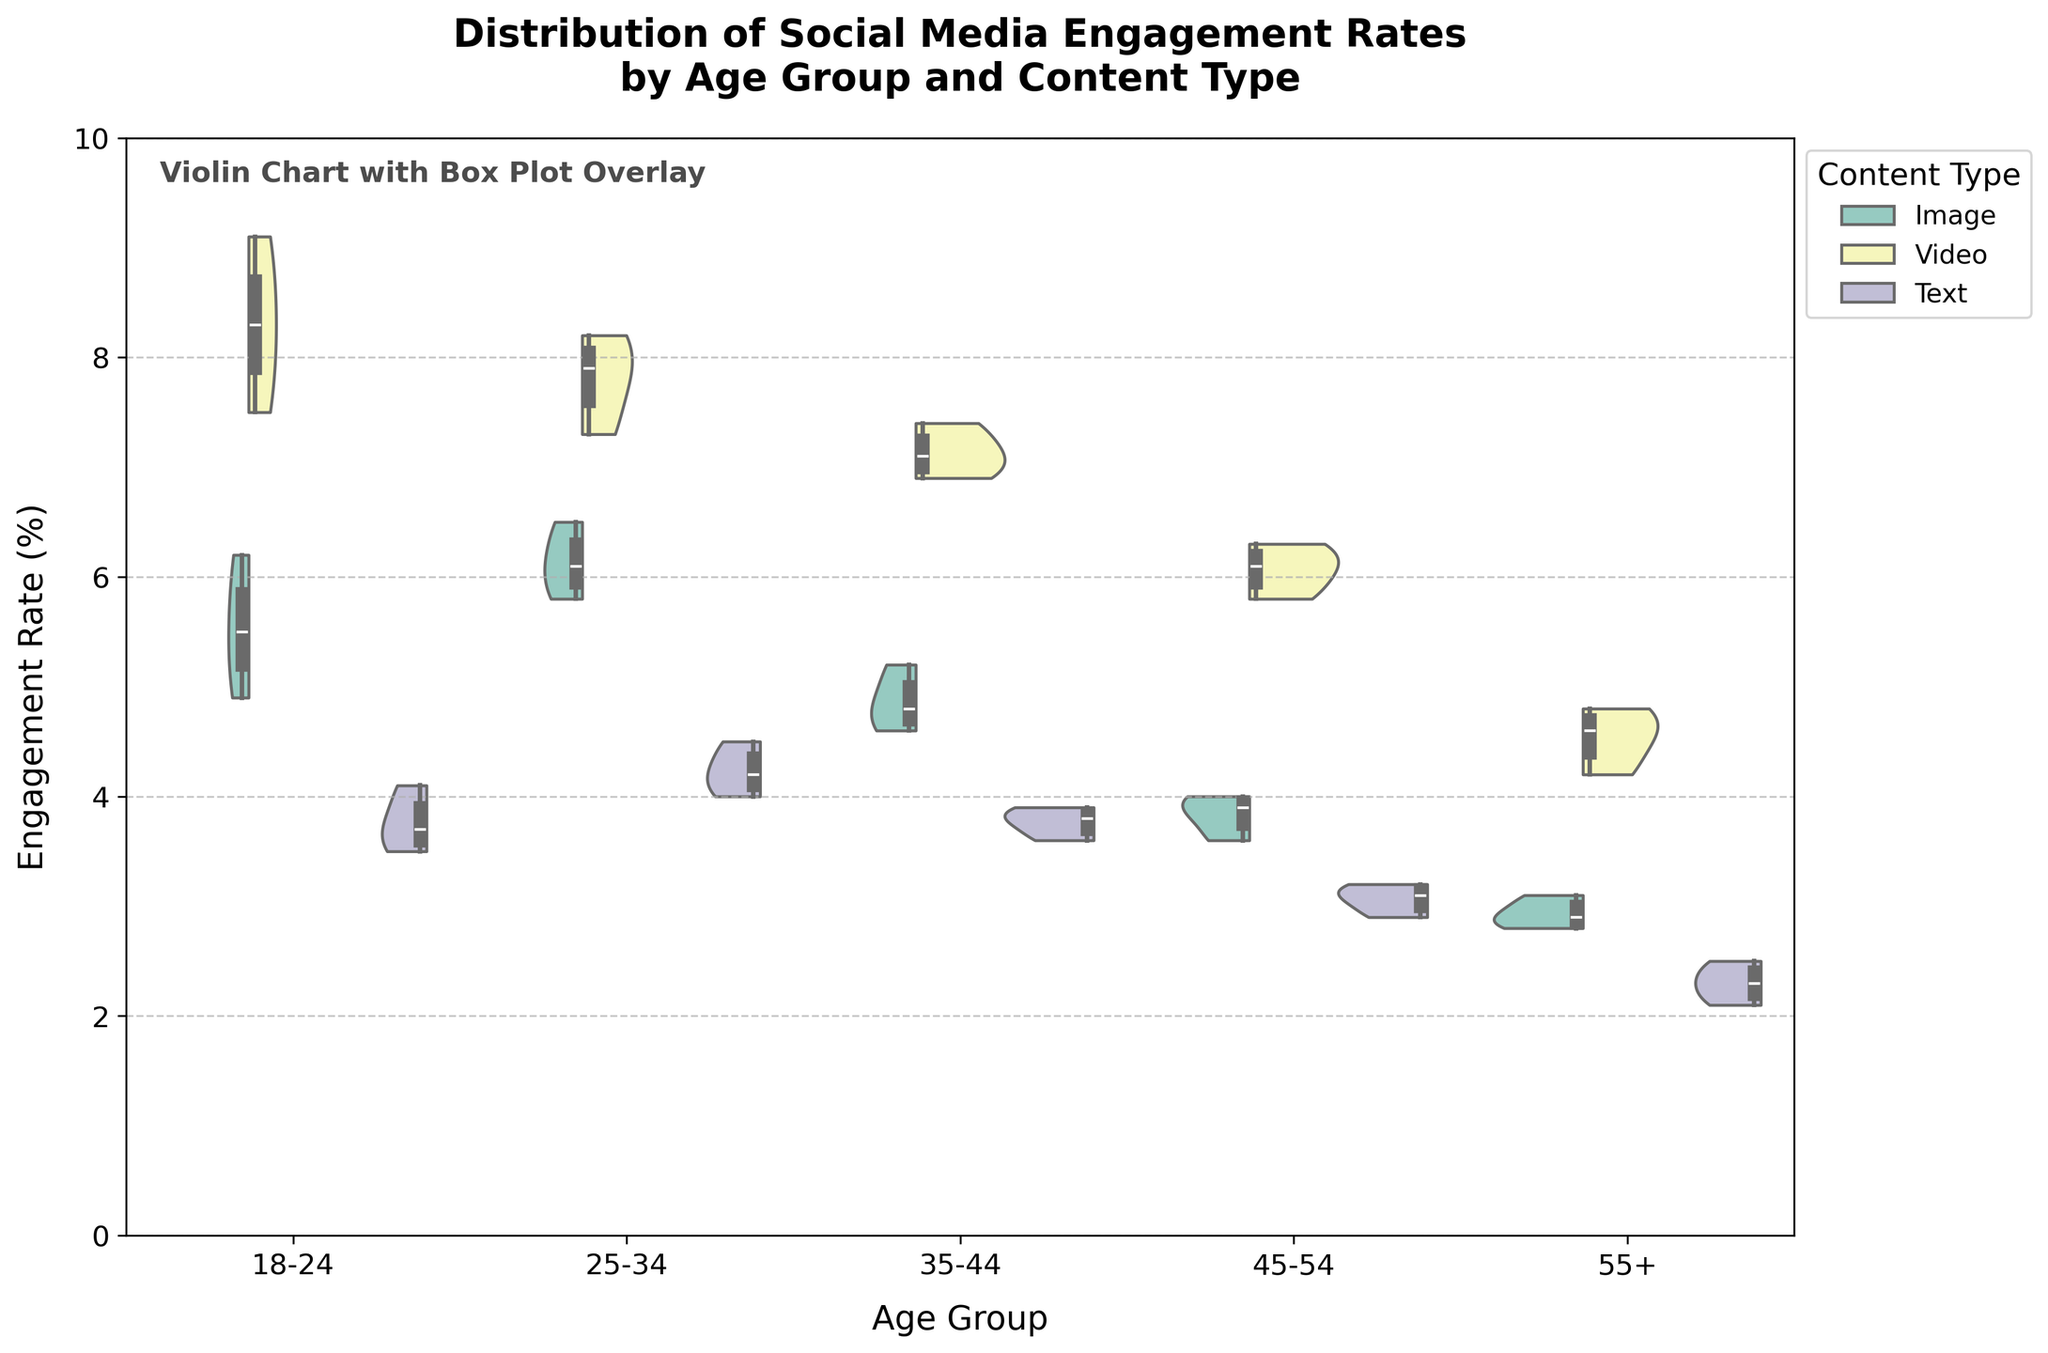What is the title of the figure? The title is located at the top of the figure. It reads, "Distribution of Social Media Engagement Rates by Age Group and Content Type."
Answer: Distribution of Social Media Engagement Rates by Age Group and Content Type Which age group shows the highest engagement rate for images? By referring to the violin shapes and box plots, for the Image content type, the 25-34 age group has the highest median engagement rate, which can be observed as the widest part of the violin plot.
Answer: 25-34 What is the general trend of engagement rates for video content across age groups? Checking the position and spread of the violins and box plots for Video content, engagement rates for video content decrease as the age group increases.
Answer: Decreasing trend Which content type has the most consistent (least variable) engagement rate for the 18-24 age group? For the 18-24 age group, the consistency can be determined by looking at the width of the violins and the spread of the box plot. For Text content, the violin is narrower and the box plot less spread out, indicating more consistent engagement rates.
Answer: Text In the 55+ age group, which content type has the lowest median engagement rate? Checking the box plots within the 55+ age group, the Text content type has the lowest median engagement rate compared to Image and Video content.
Answer: Text How do the engagement rates of text content compare between the 18-24 and 45-54 age groups? Observing the violin plots and box plots, the median engagement rate for Text content is higher in the 18-24 age group compared to the 45-54 age group, indicated by the position of the box plot within the violin.
Answer: Higher in 18-24 What can you conclude about the variability of engagement rates for video content in the 45-54 age group? The width of the violin plot for Video content in the 45-54 age group indicates the variability. The video content shows a moderately wide violin plot, indicating a relatively high variability in engagement rates.
Answer: High variability Which content type shows the highest maximum engagement rate for the 18-24 age group? The highest maximum value can be observed from the upper whisker of the box plot within the violin plot. For the 18-24 age group, Video content type shows the highest maximum engagement rate.
Answer: Video Is there any age group where the engagement rates for image content are higher than for video content? Reviewing the overlapped violin plots and box plots, there is no age group where the median engagement rate for Image is higher than that for Video; Video is consistently higher.
Answer: No 